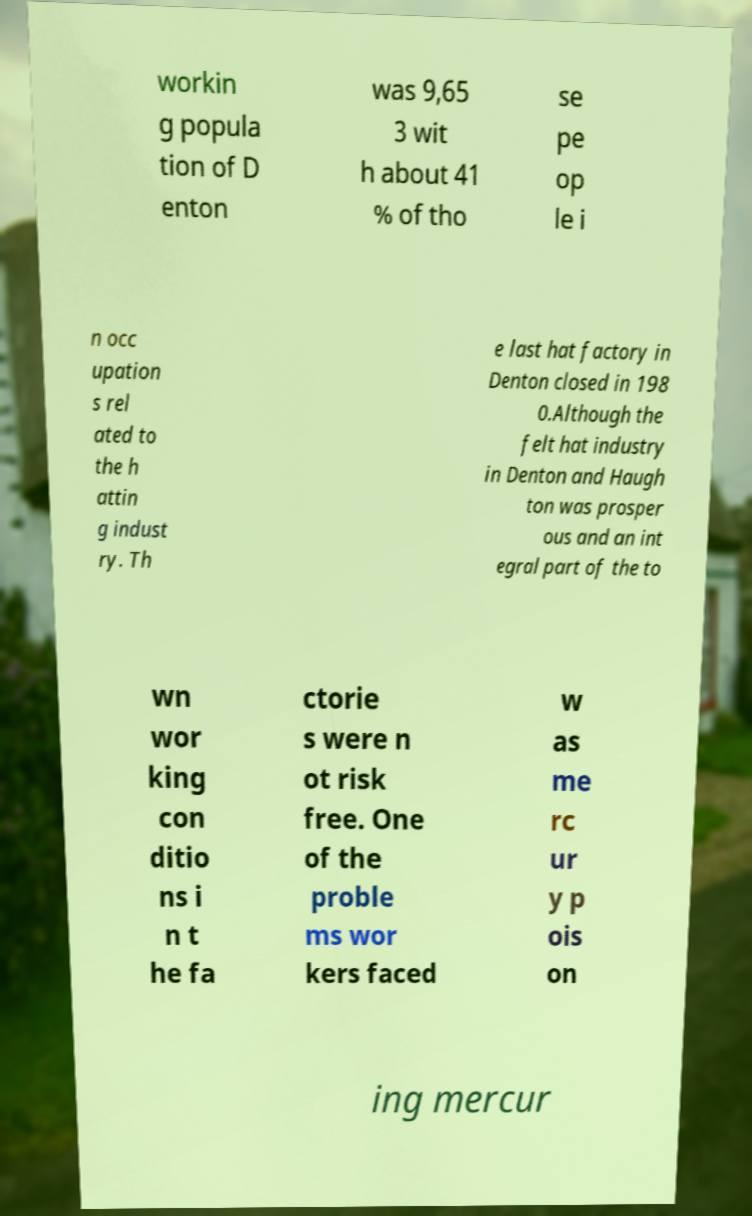What messages or text are displayed in this image? I need them in a readable, typed format. workin g popula tion of D enton was 9,65 3 wit h about 41 % of tho se pe op le i n occ upation s rel ated to the h attin g indust ry. Th e last hat factory in Denton closed in 198 0.Although the felt hat industry in Denton and Haugh ton was prosper ous and an int egral part of the to wn wor king con ditio ns i n t he fa ctorie s were n ot risk free. One of the proble ms wor kers faced w as me rc ur y p ois on ing mercur 